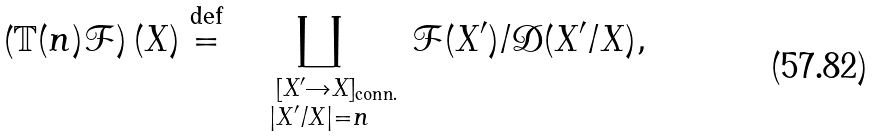<formula> <loc_0><loc_0><loc_500><loc_500>\left ( \mathbb { T } ( n ) \mathcal { F } \right ) ( X ) \overset { \text {def} } { = } \, \coprod _ { \substack { \quad [ X ^ { \prime } \rightarrow X ] _ { \text {conn.} } \\ | X ^ { \prime } / X | = n } } \, \mathcal { F } ( X ^ { \prime } ) / \mathcal { D } ( X ^ { \prime } / X ) ,</formula> 